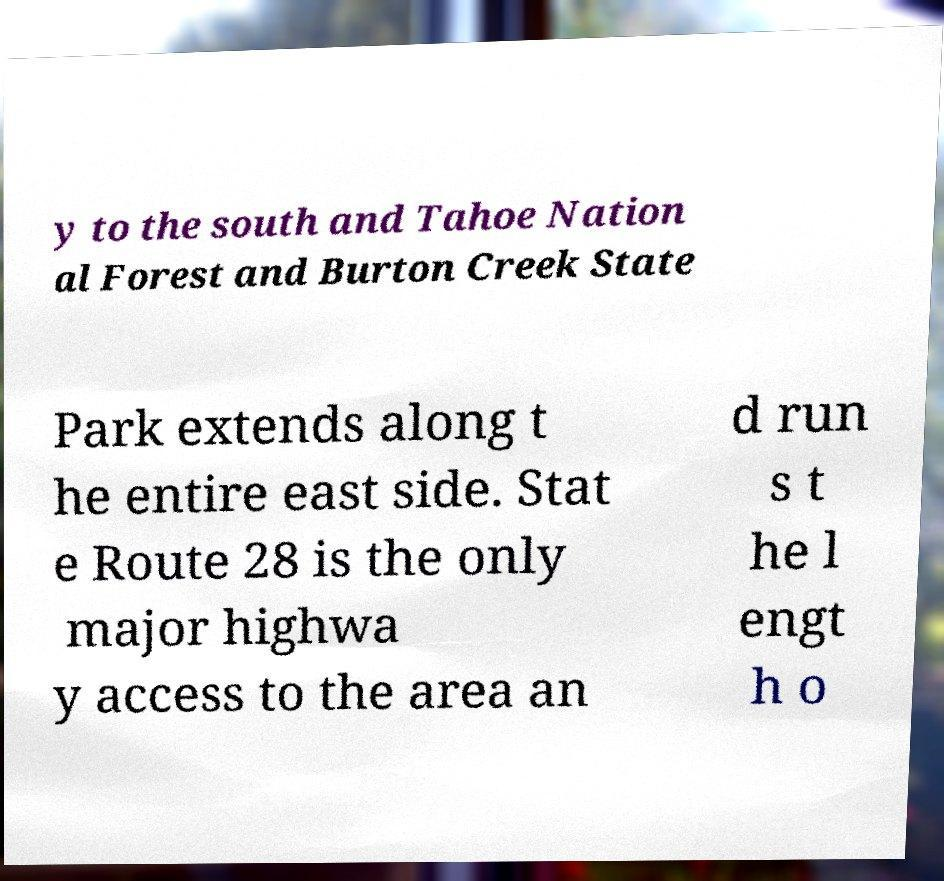For documentation purposes, I need the text within this image transcribed. Could you provide that? y to the south and Tahoe Nation al Forest and Burton Creek State Park extends along t he entire east side. Stat e Route 28 is the only major highwa y access to the area an d run s t he l engt h o 